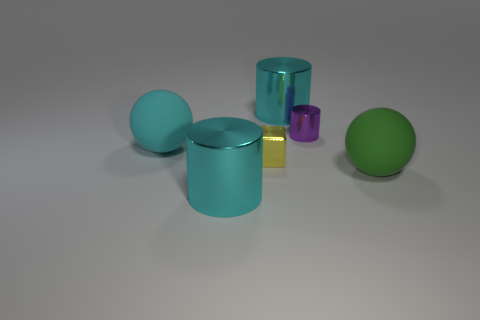Is there anything else that is the same shape as the yellow metal thing?
Offer a terse response. No. There is a small yellow object; what number of yellow blocks are to the left of it?
Your answer should be very brief. 0. Are any big cyan metal cylinders visible?
Your answer should be compact. Yes. There is a matte ball that is right of the cyan metal cylinder that is left of the big metallic cylinder that is behind the big cyan rubber sphere; what color is it?
Provide a short and direct response. Green. There is a matte object behind the tiny yellow metallic object; are there any big metal cylinders that are in front of it?
Provide a short and direct response. Yes. Do the large matte thing on the right side of the cyan matte object and the large rubber sphere behind the tiny cube have the same color?
Keep it short and to the point. No. What number of shiny objects have the same size as the purple cylinder?
Make the answer very short. 1. Is the size of the cylinder that is to the left of the cube the same as the purple metal cylinder?
Provide a short and direct response. No. The purple thing is what shape?
Keep it short and to the point. Cylinder. Does the cyan thing behind the cyan sphere have the same material as the large green object?
Make the answer very short. No. 